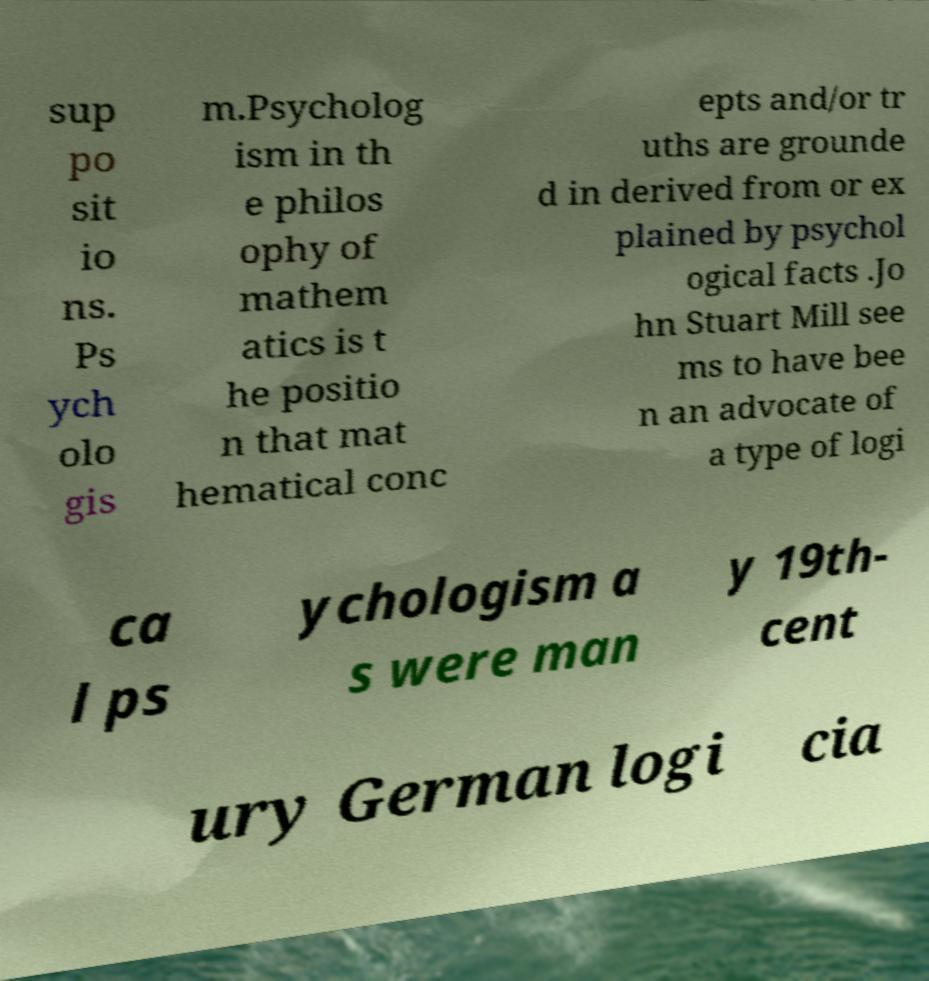Can you read and provide the text displayed in the image?This photo seems to have some interesting text. Can you extract and type it out for me? sup po sit io ns. Ps ych olo gis m.Psycholog ism in th e philos ophy of mathem atics is t he positio n that mat hematical conc epts and/or tr uths are grounde d in derived from or ex plained by psychol ogical facts .Jo hn Stuart Mill see ms to have bee n an advocate of a type of logi ca l ps ychologism a s were man y 19th- cent ury German logi cia 